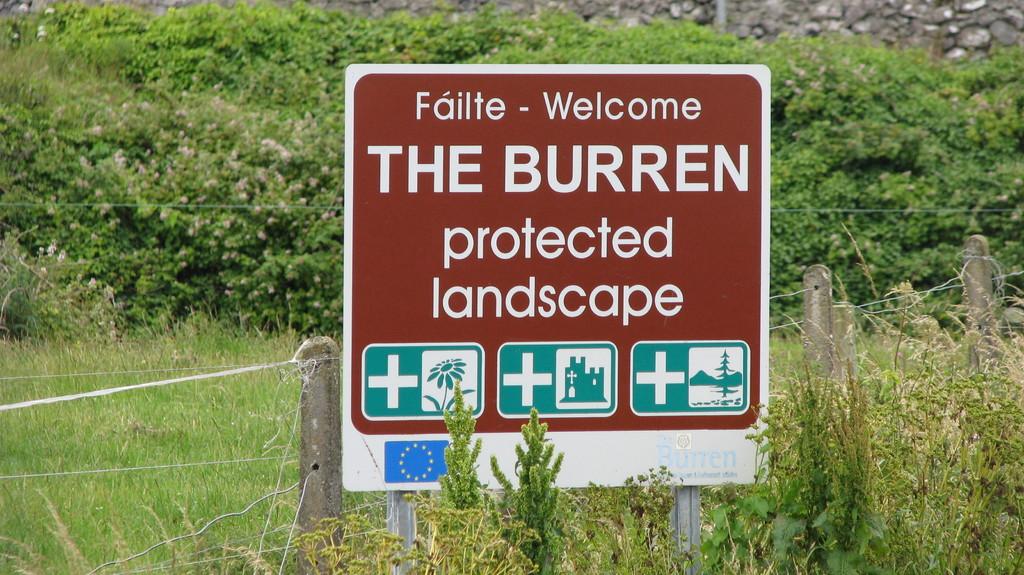What is protected landscape?
Your answer should be very brief. The burren. Where is this?
Offer a very short reply. The burren. 